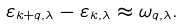Convert formula to latex. <formula><loc_0><loc_0><loc_500><loc_500>\varepsilon _ { k + q , \lambda } - \varepsilon _ { k , \lambda } \approx \omega _ { q , \lambda } .</formula> 